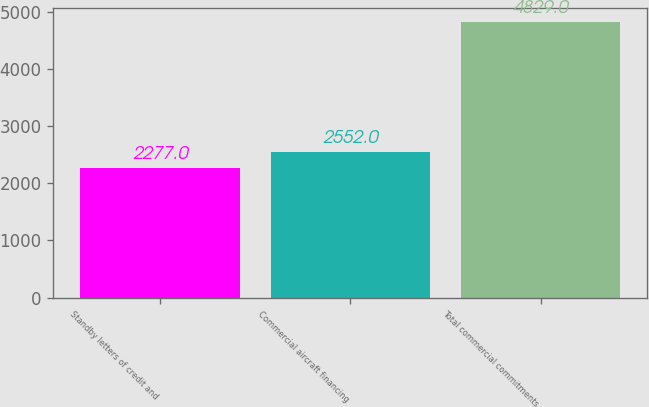<chart> <loc_0><loc_0><loc_500><loc_500><bar_chart><fcel>Standby letters of credit and<fcel>Commercial aircraft financing<fcel>Total commercial commitments<nl><fcel>2277<fcel>2552<fcel>4829<nl></chart> 